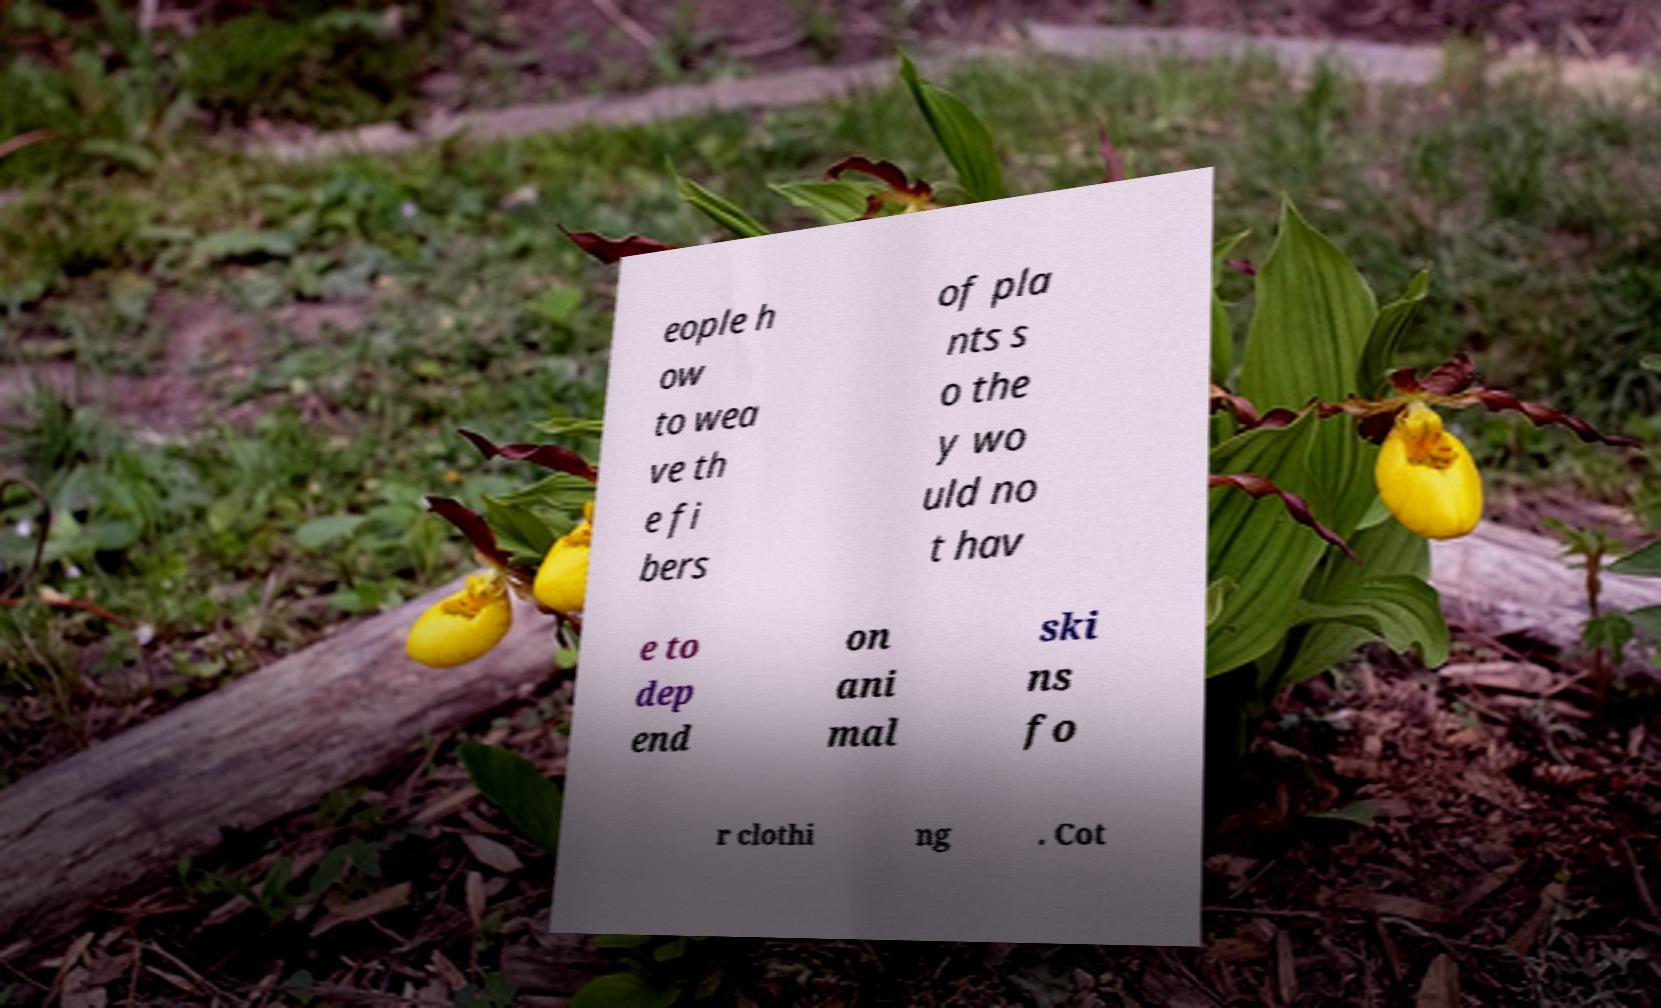Can you read and provide the text displayed in the image?This photo seems to have some interesting text. Can you extract and type it out for me? eople h ow to wea ve th e fi bers of pla nts s o the y wo uld no t hav e to dep end on ani mal ski ns fo r clothi ng . Cot 